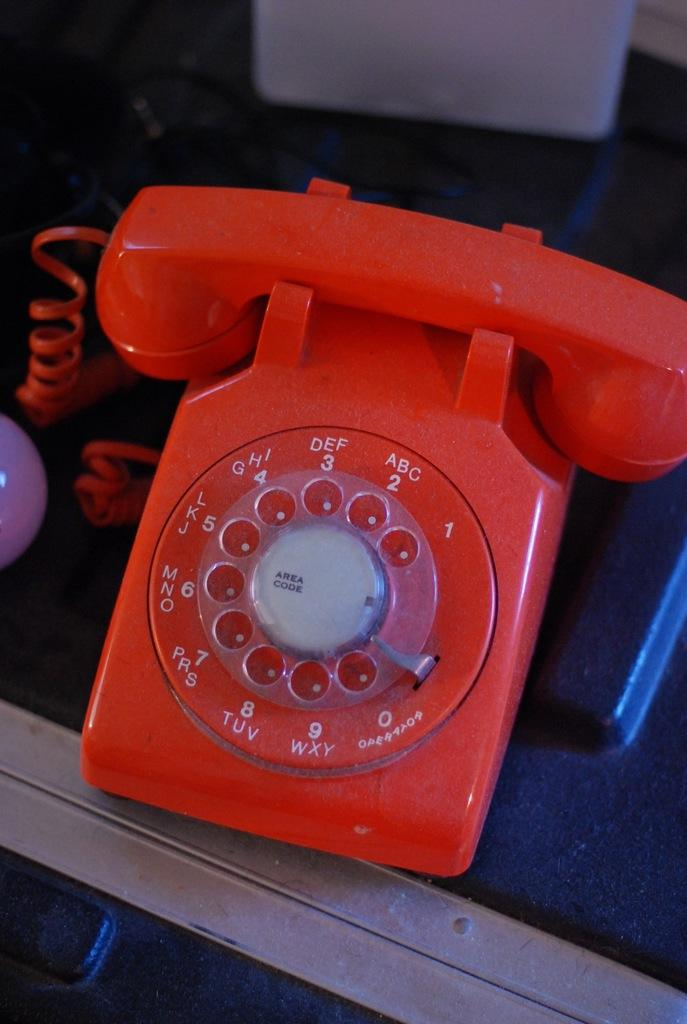<image>
Provide a brief description of the given image. Red telephone that says "Area Code" in the middle. 